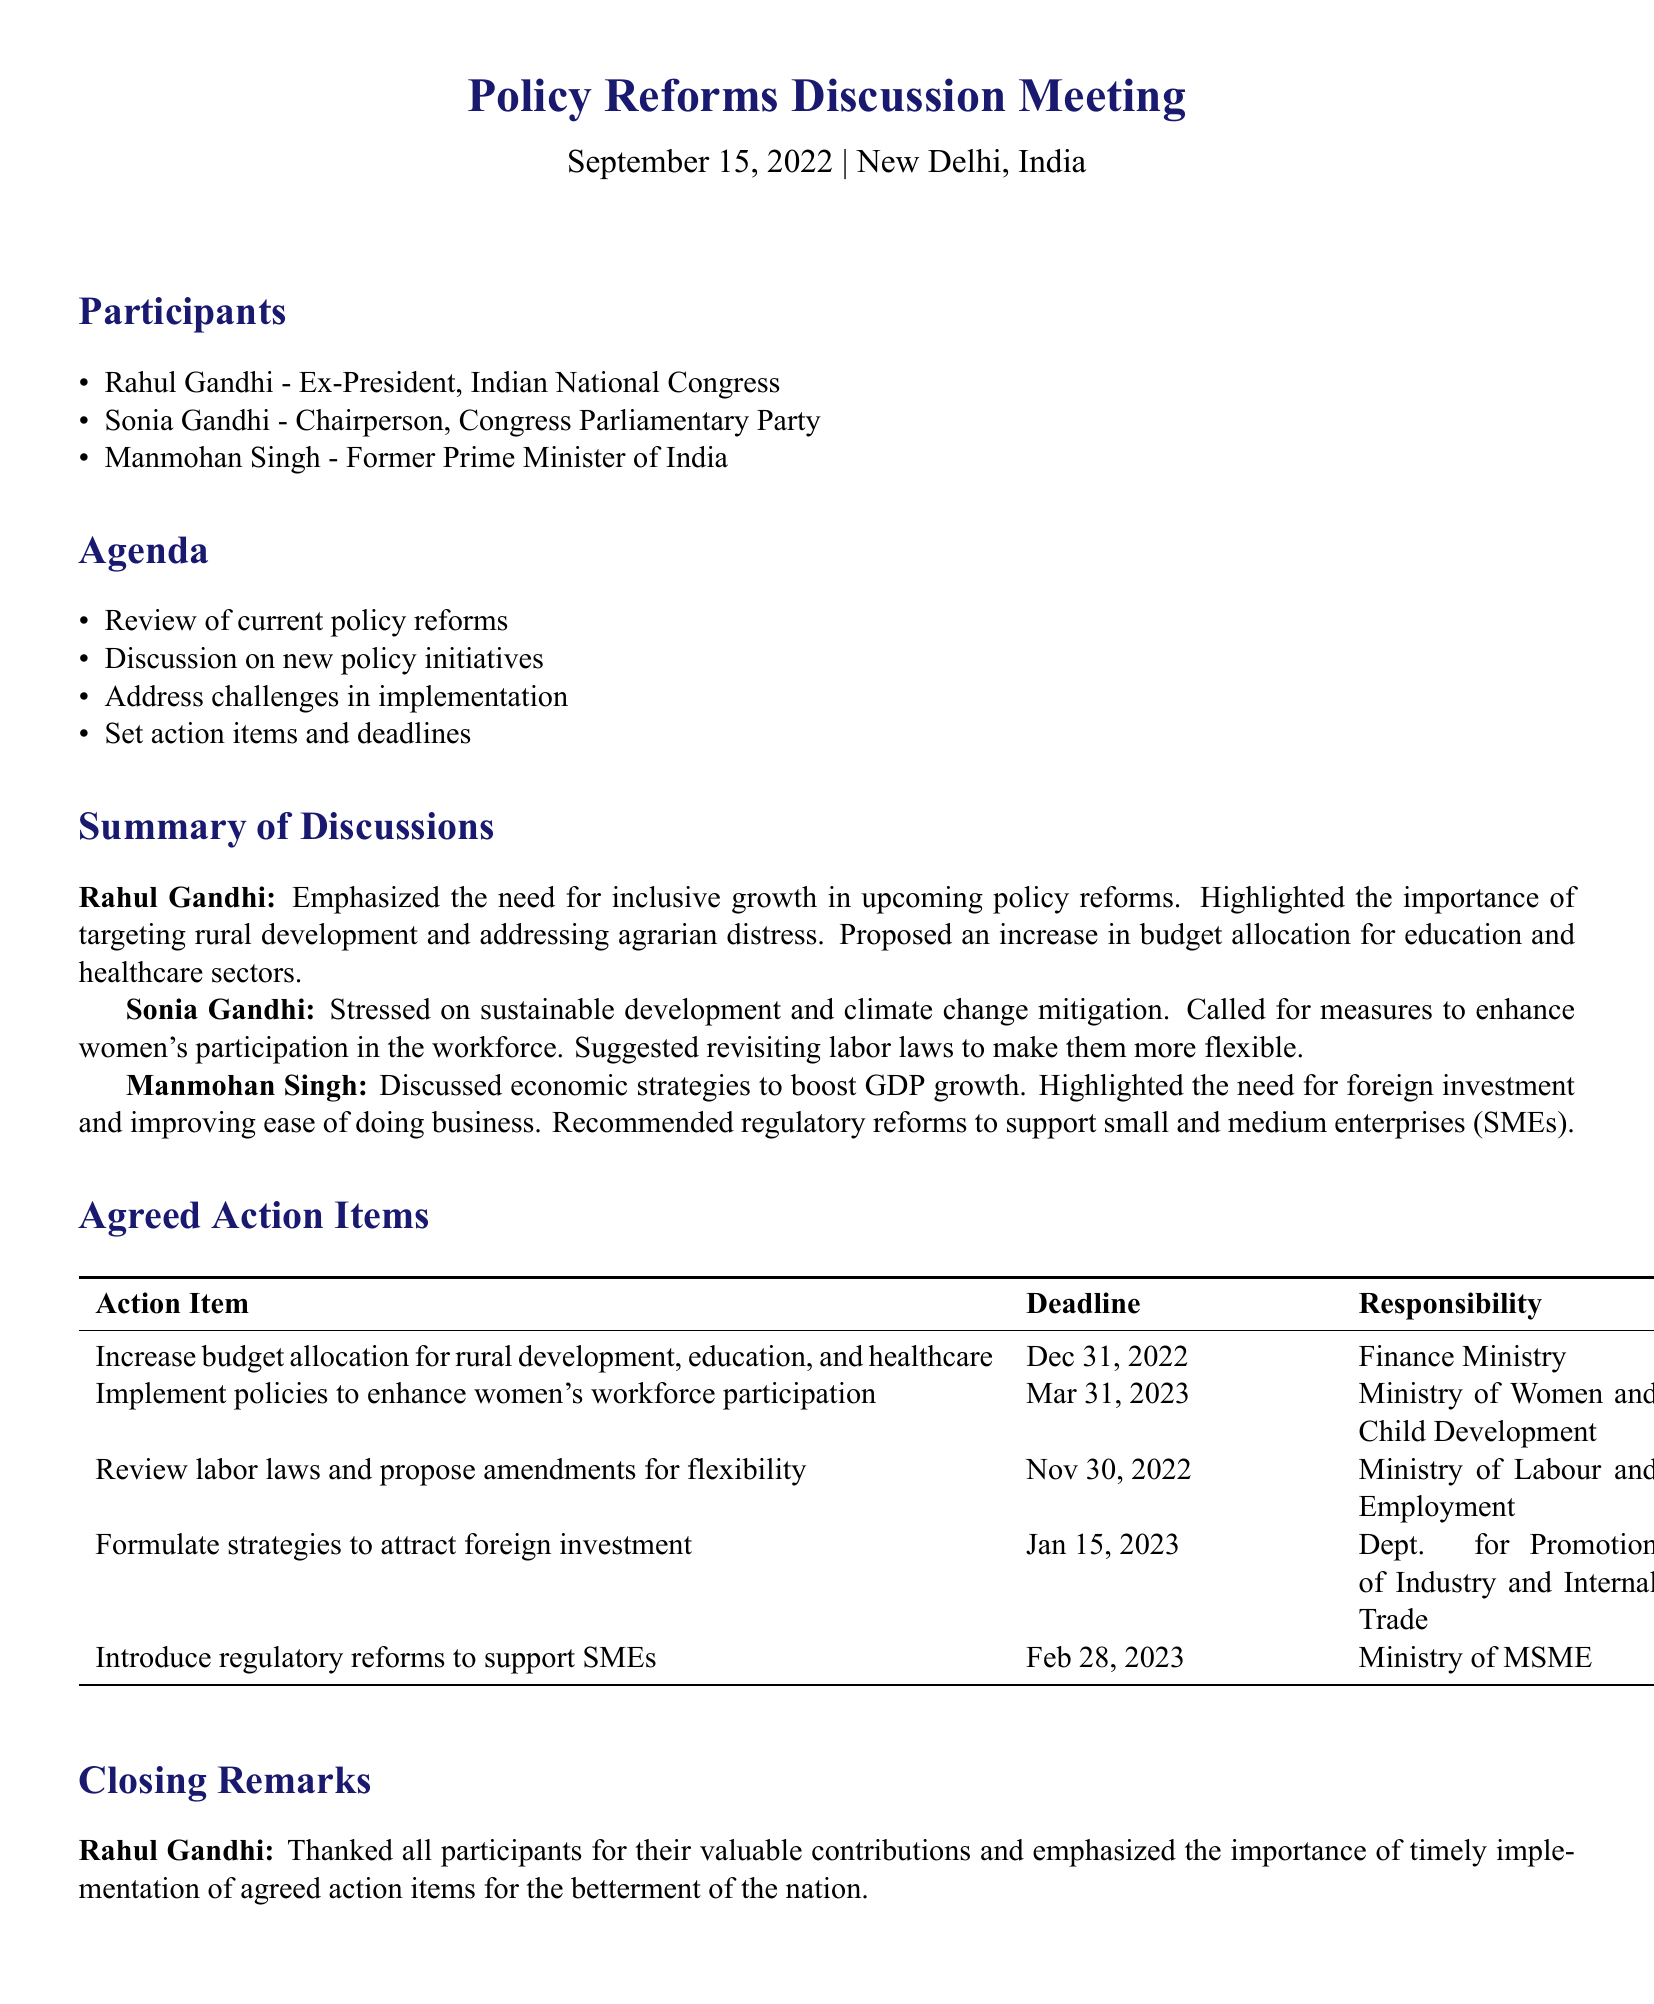What is the date of the meeting? The meeting is held on September 15, 2022.
Answer: September 15, 2022 Who is the Chairperson of the Congress Parliamentary Party? Sonia Gandhi is identified as the Chairperson in the participants list.
Answer: Sonia Gandhi What is one of the key topics discussed by Rahul Gandhi? He discussed the need for inclusive growth targeting rural development and agrarian distress.
Answer: Inclusive growth What is the deadline for reviewing labor laws? The agreed deadline for this action item is November 30, 2022.
Answer: November 30, 2022 Which ministry is responsible for implementing policies to enhance women's workforce participation? The Ministry of Women and Child Development is assigned this responsibility.
Answer: Ministry of Women and Child Development What is Manmohan Singh's recommendation regarding foreign investment? He emphasized the need for strategies to attract foreign investment.
Answer: Attract foreign investment Which participant emphasized sustainable development? Sonia Gandhi stressed the importance of sustainable development in her contribution.
Answer: Sonia Gandhi What financial allocation increase does Rahul Gandhi propose? He proposed an increase in budget allocation for education and healthcare sectors.
Answer: Education and healthcare sectors What is the deadline for introducing regulatory reforms to support SMEs? The deadline set for this action item is February 28, 2023.
Answer: February 28, 2023 